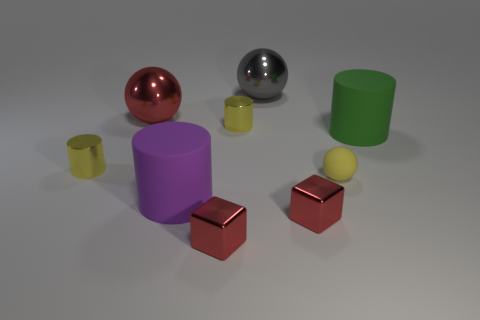What number of other objects are the same color as the tiny matte thing?
Offer a very short reply. 2. There is a matte object in front of the yellow ball; is it the same size as the small yellow matte object?
Offer a very short reply. No. There is a large object that is both in front of the large red metal thing and left of the tiny matte ball; what color is it?
Ensure brevity in your answer.  Purple. How many objects are big brown metallic things or red objects that are in front of the big red metal ball?
Provide a succinct answer. 2. There is a large object that is to the left of the large purple thing left of the metallic block right of the gray metallic ball; what is it made of?
Your answer should be compact. Metal. Is there anything else that is made of the same material as the big purple object?
Offer a terse response. Yes. Does the matte object that is right of the yellow ball have the same color as the small rubber object?
Ensure brevity in your answer.  No. How many yellow things are either big spheres or cubes?
Your response must be concise. 0. What number of other objects are there of the same shape as the big green rubber object?
Provide a succinct answer. 3. Does the large gray sphere have the same material as the purple object?
Make the answer very short. No. 